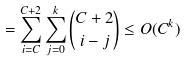Convert formula to latex. <formula><loc_0><loc_0><loc_500><loc_500>= \sum _ { i = C } ^ { C + 2 } \sum _ { j = 0 } ^ { k } \binom { C + 2 } { i - j } \leq O ( C ^ { k } ) \\</formula> 